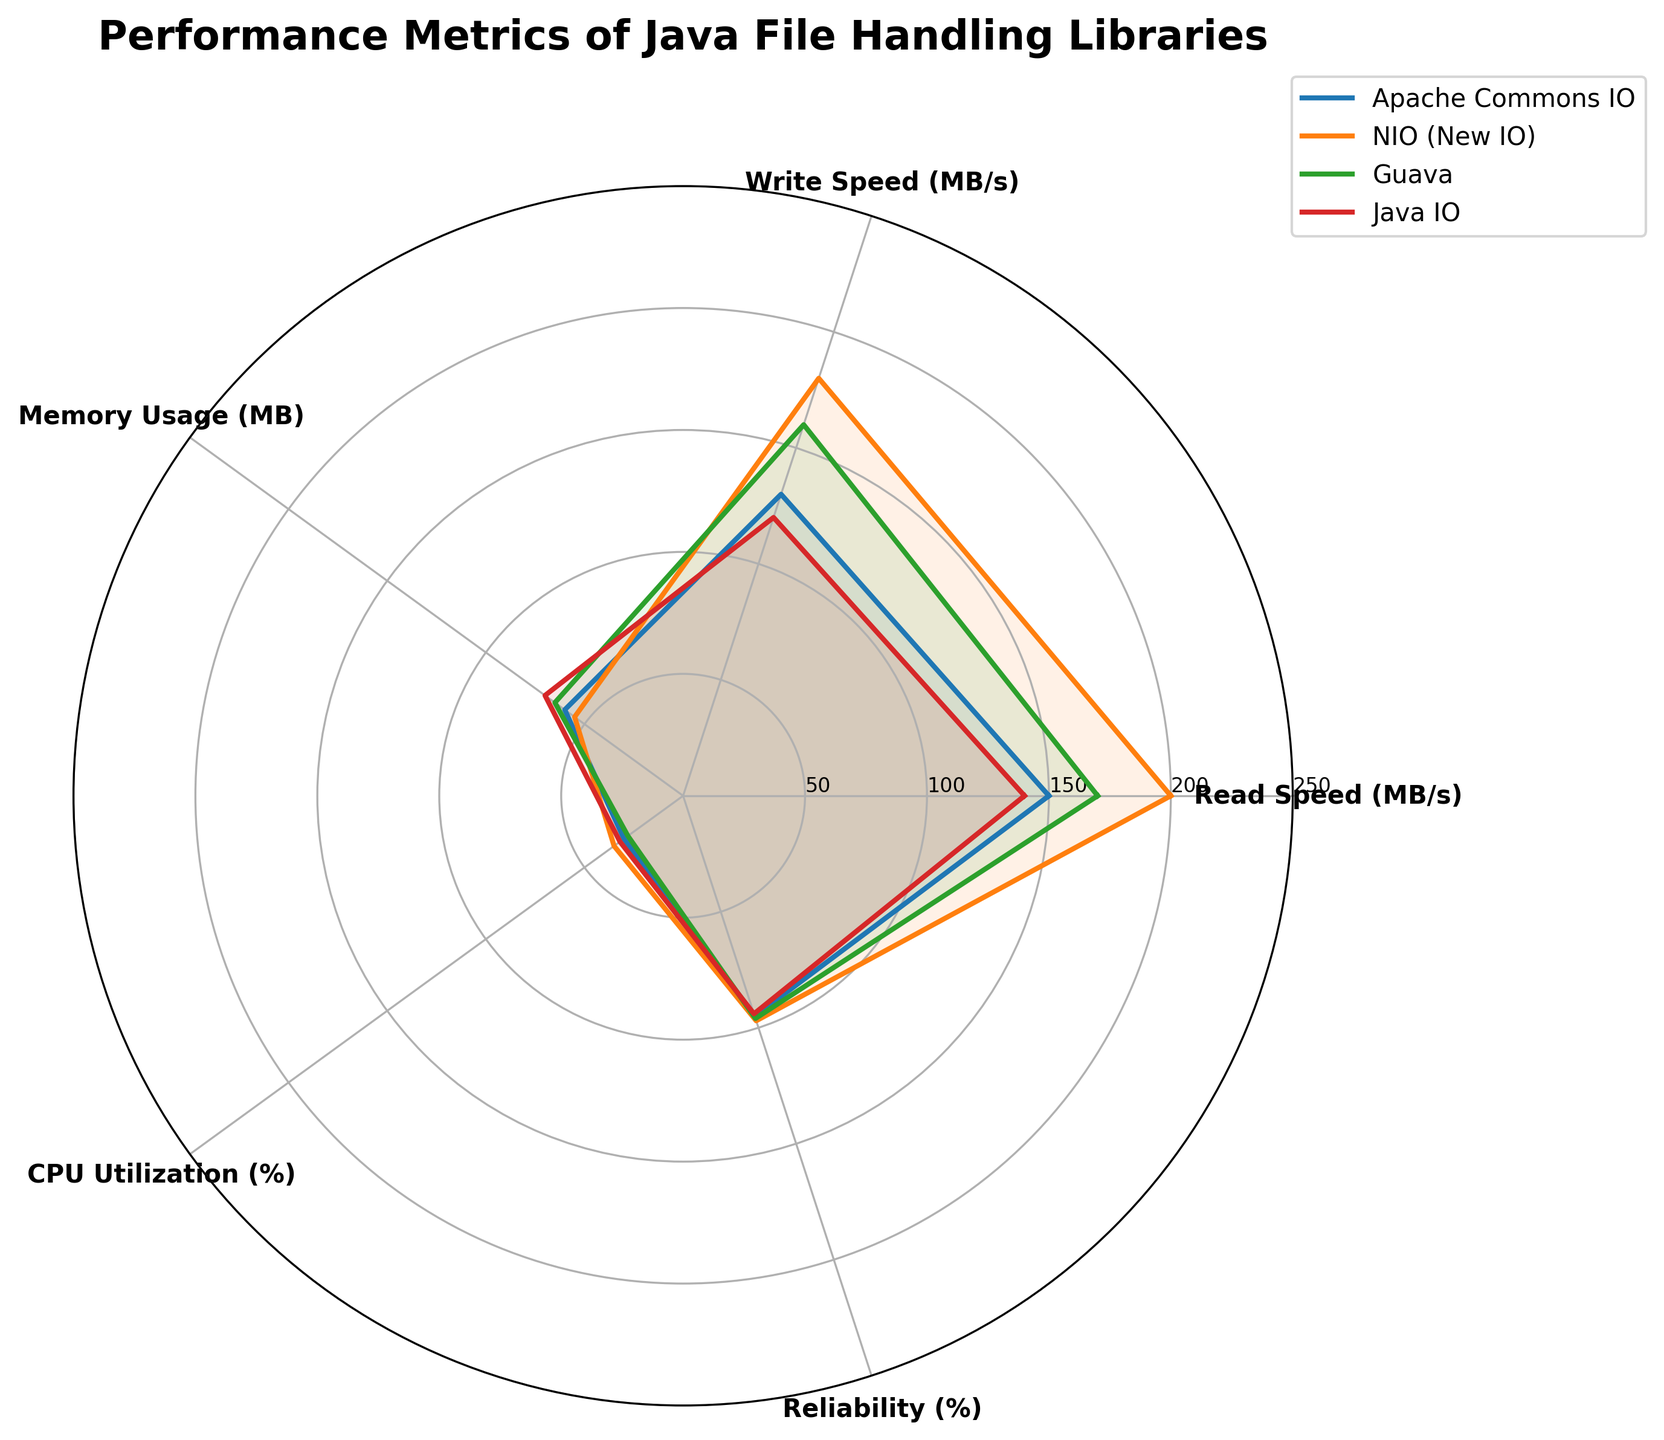What is the title of the chart? The title is located at the top of the chart, and typically summarizes the main subject of the figure. In this case, look above the radar chart.
Answer: Performance Metrics of Java File Handling Libraries How many libraries are compared in the chart? Libraries are uniquely identified by their labels, which are usually colored lines or shaded regions within the radar chart. Count the distinct labels.
Answer: 4 Which library has the highest read speed? The read speed is plotted on one of the axes in the radar chart. Look for where the values extend furthest from the center on the read speed axis.
Answer: NIO (New IO) Which metric shows the most consistent performance across all libraries? Look for the axis where the values of all libraries are most similar to each other, meaning the lines are grouped closely together.
Answer: Reliability (%) Which library uses the most memory? The library with the highest memory usage will have the line furthest from the center on the memory usage axis. Look for the highest point on the memory usage axis.
Answer: Java IO What is the average write speed of all libraries? Write down the individual write speeds for each library and calculate their sum, then divide by the number of libraries. (130 + 180 + 160 + 120) / 4.
Answer: 147.5 MB/s Which two libraries have the closest CPU utilization percentages? Compare the values on the CPU utilization axis and evaluate the differences. The two closest values will belong to the libraries being asked for.
Answer: Apache Commons IO and Java IO Which library has the lowest overall scores considering all metrics combined? Examine the areas covered by each library on all axes; the smallest covered area indicates the lowest overall performance.
Answer: Java IO What’s the combined read and write speed of Guava? Add the read speed and the write speed together for the Guava library. (170 + 160).
Answer: 330 MB/s Between NIO (New IO) and Guava, which library is more reliable? Look at the reliability percentage axis and compare the values directly.
Answer: NIO (New IO) 